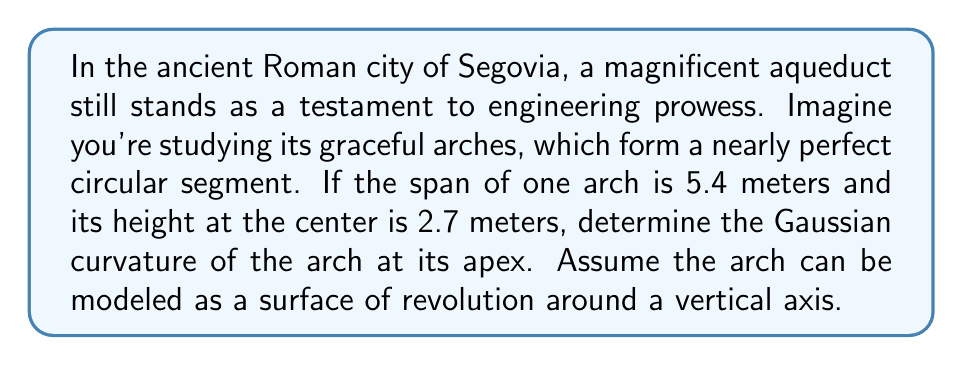Can you solve this math problem? Let's approach this step-by-step, using differential geometry to determine the Gaussian curvature:

1) First, we need to find the radius of the circle that forms the arch. We can do this using the equation of a circle:

   $$(x-h)^2 + (y-k)^2 = r^2$$

   Where $(h,k)$ is the center of the circle.

2) In our case, if we place the origin at the base of the arch, we have:

   $x^2 + (y-r)^2 = r^2$

   Where $r$ is the radius we're looking for.

3) We know two points on this circle: $(0,0)$ and $(2.7, 2.7)$ (half the span and the height).

4) Substituting these points into the equation:

   $2.7^2 + (2.7-r)^2 = r^2$
   $7.29 + (2.7-r)^2 = r^2$

5) Solving this equation:

   $7.29 + 7.29 - 5.4r + r^2 = r^2$
   $14.58 = 5.4r$
   $r = 2.7$

6) Now that we have the radius, we can model this as a surface of revolution. The parametric equations for this surface would be:

   $x = r \cos \theta$
   $y = r \sin \theta$
   $z = r - \sqrt{r^2 - x^2}$

7) To find the Gaussian curvature, we need to calculate the principal curvatures $\kappa_1$ and $\kappa_2$.

8) For a surface of revolution, at the apex:
   
   $\kappa_1 = \frac{1}{r}$ (meridional curvature)
   $\kappa_2 = \frac{1}{r}$ (circumferential curvature)

9) The Gaussian curvature $K$ is the product of these principal curvatures:

   $K = \kappa_1 \kappa_2 = (\frac{1}{r})(\frac{1}{r}) = \frac{1}{r^2}$

10) Substituting our value for $r$:

    $K = \frac{1}{(2.7)^2} = \frac{1}{7.29} \approx 0.137 \text{ m}^{-2}$

Thus, the Gaussian curvature of the arch at its apex is approximately 0.137 m^(-2).
Answer: $0.137 \text{ m}^{-2}$ 